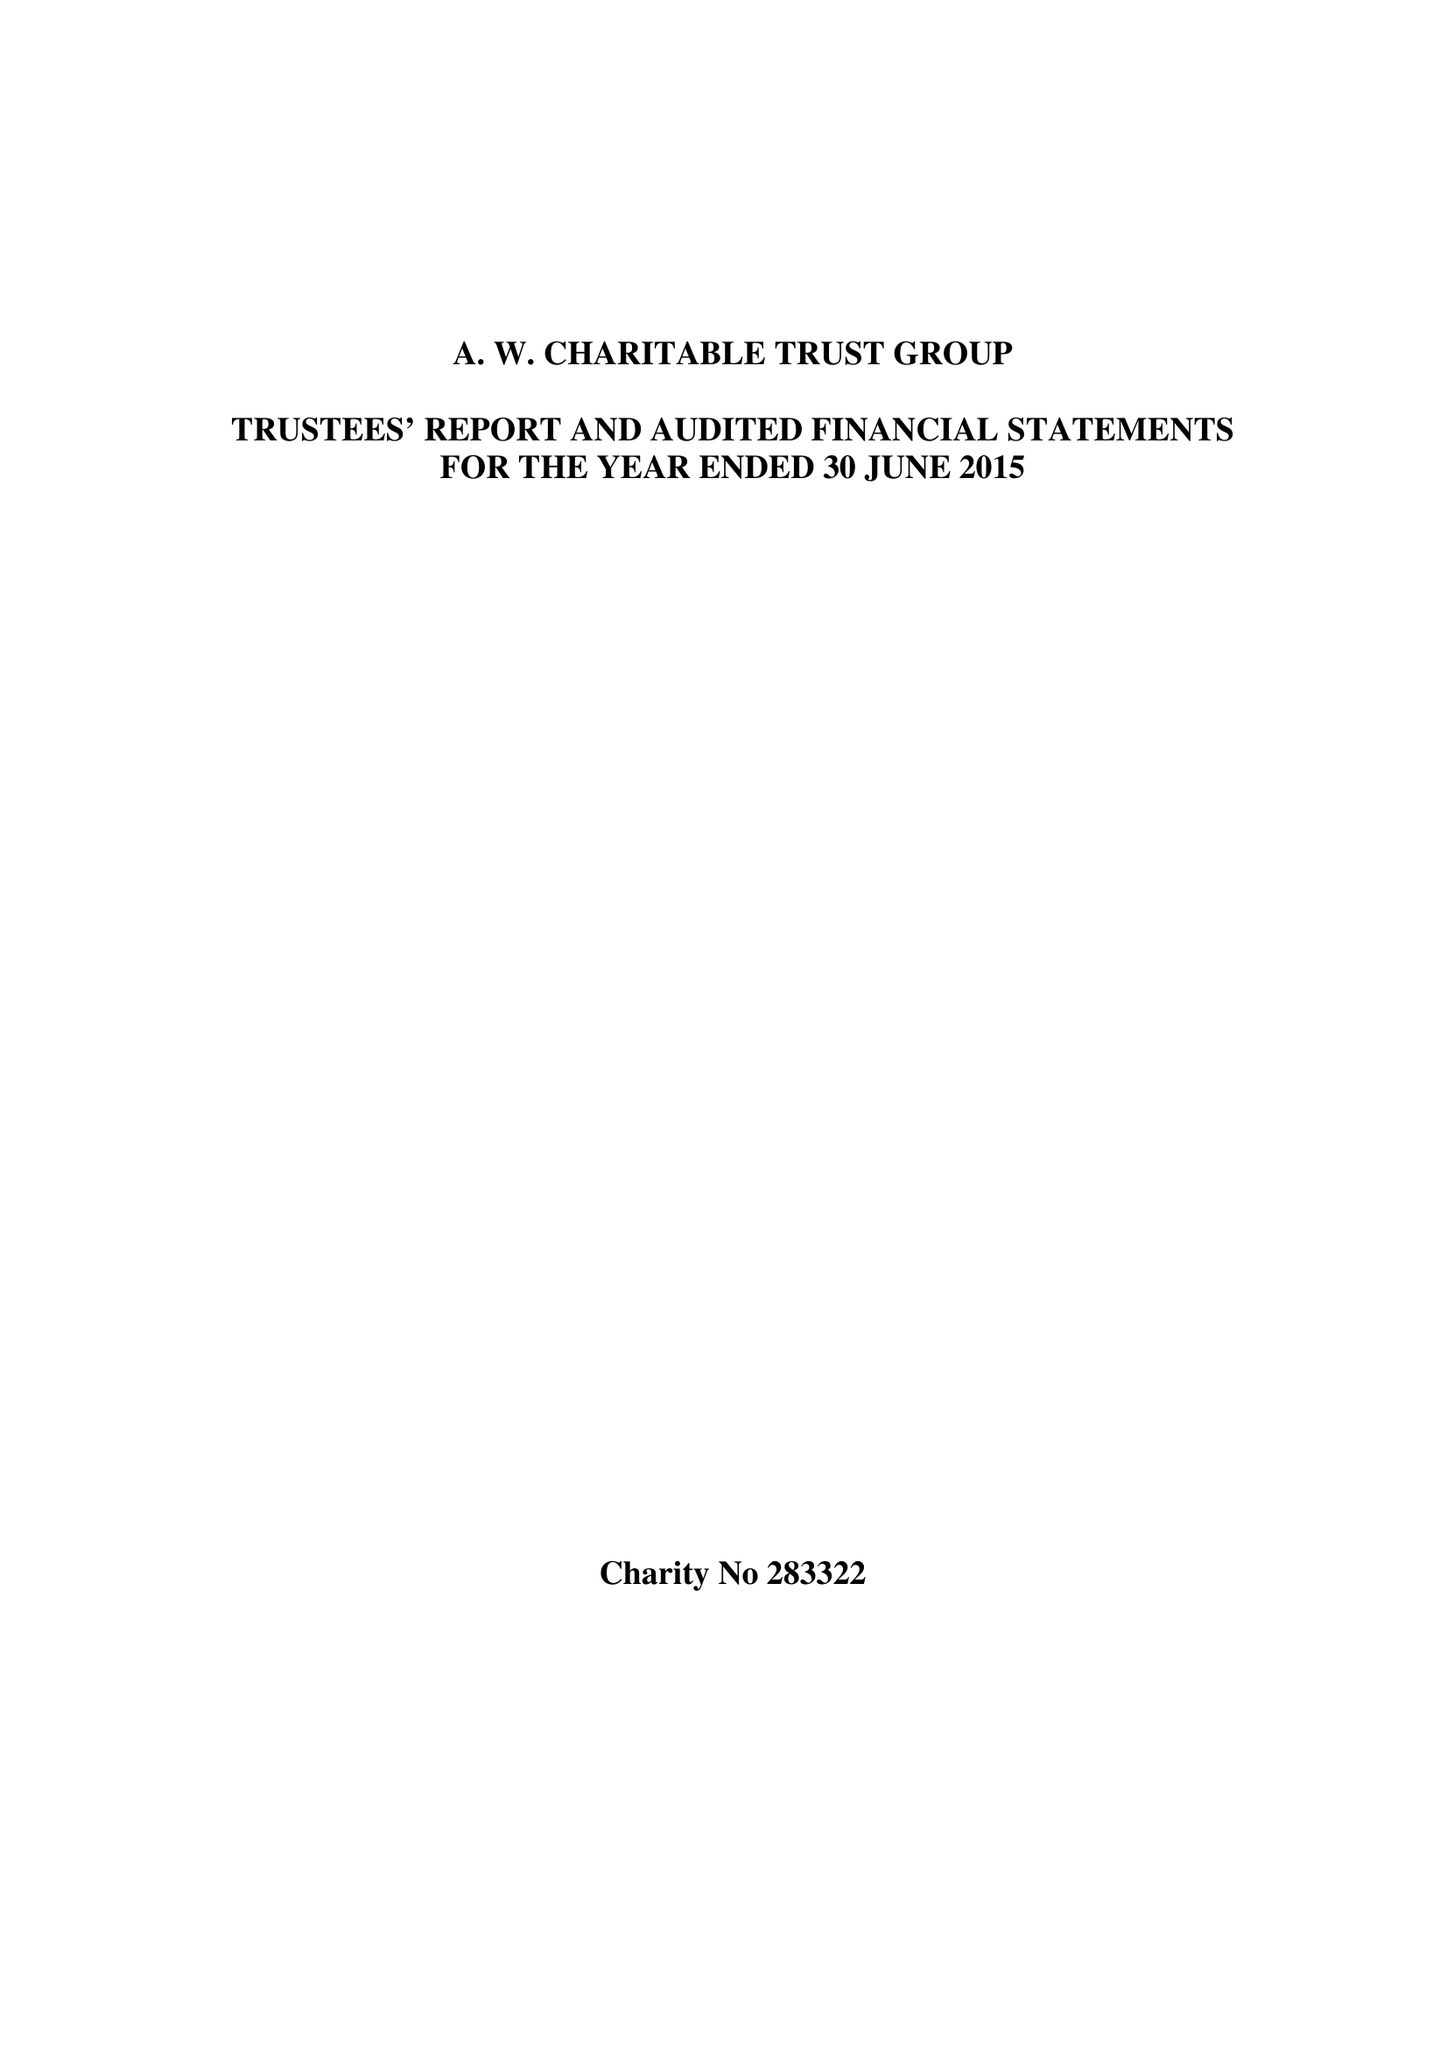What is the value for the address__street_line?
Answer the question using a single word or phrase. None 